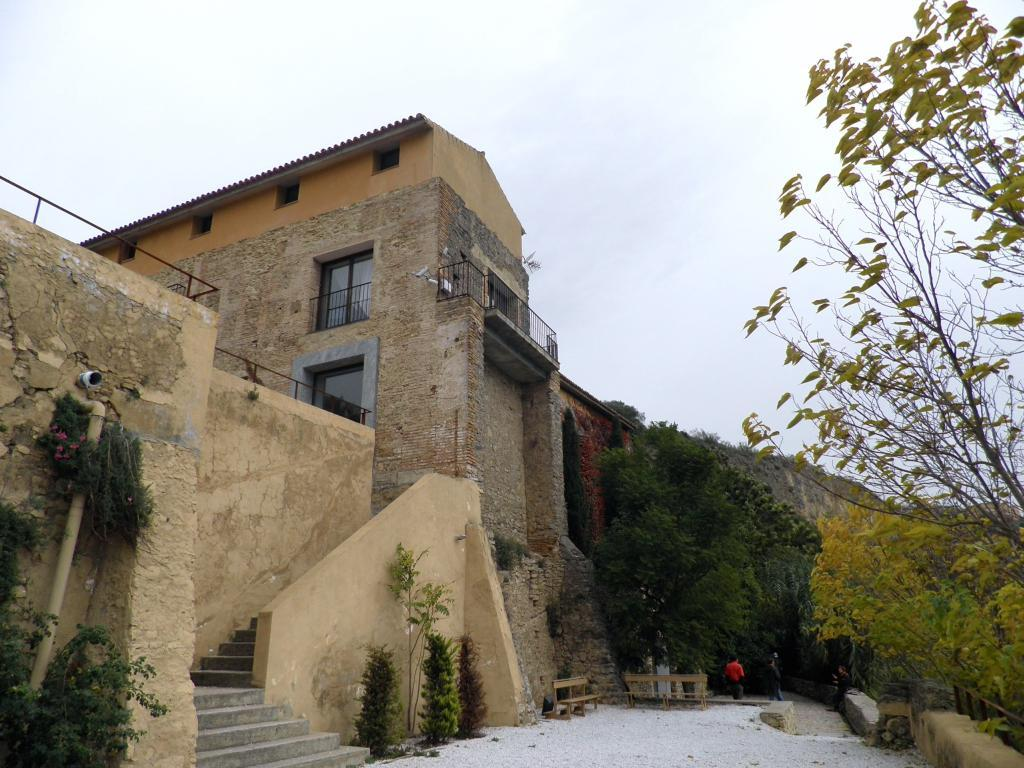What is the main structure in the center of the image? There is a building in the center of the image. What type of vegetation is present at the bottom of the image? There are bushes and trees at the bottom of the image. Can you describe the people visible in the image? People are visible in the image, but their specific actions or characteristics are not mentioned in the provided facts. What type of seating is available in the image? There are benches in the image. What is visible at the top of the image? The sky is visible at the top of the image. What type of bead is used to decorate the plants in the image? There is no mention of beads or decorations on plants in the provided facts. The image only mentions bushes and trees, without any reference to beads or decorations. 